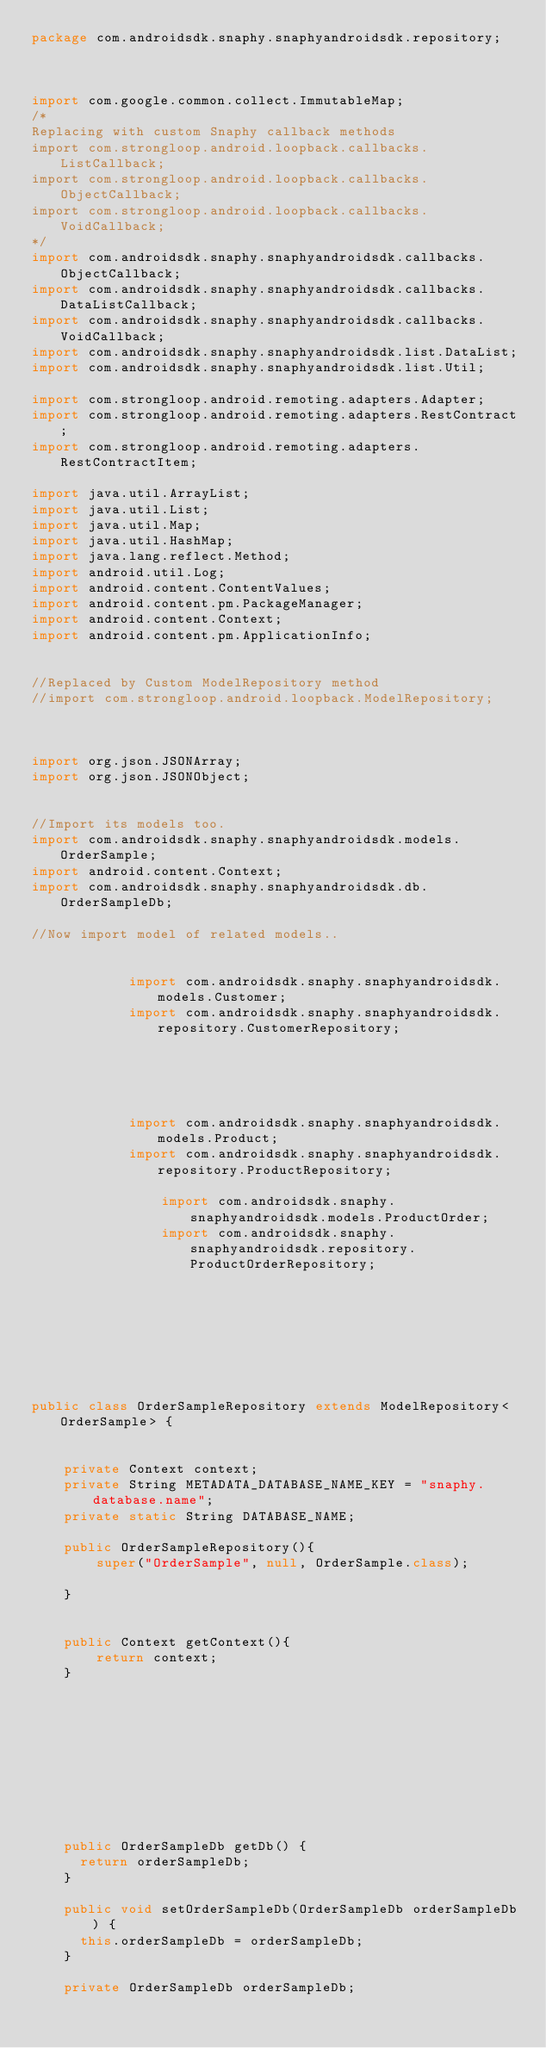Convert code to text. <code><loc_0><loc_0><loc_500><loc_500><_Java_>package com.androidsdk.snaphy.snaphyandroidsdk.repository;



import com.google.common.collect.ImmutableMap;
/*
Replacing with custom Snaphy callback methods
import com.strongloop.android.loopback.callbacks.ListCallback;
import com.strongloop.android.loopback.callbacks.ObjectCallback;
import com.strongloop.android.loopback.callbacks.VoidCallback;
*/
import com.androidsdk.snaphy.snaphyandroidsdk.callbacks.ObjectCallback;
import com.androidsdk.snaphy.snaphyandroidsdk.callbacks.DataListCallback;
import com.androidsdk.snaphy.snaphyandroidsdk.callbacks.VoidCallback;
import com.androidsdk.snaphy.snaphyandroidsdk.list.DataList;
import com.androidsdk.snaphy.snaphyandroidsdk.list.Util;

import com.strongloop.android.remoting.adapters.Adapter;
import com.strongloop.android.remoting.adapters.RestContract;
import com.strongloop.android.remoting.adapters.RestContractItem;

import java.util.ArrayList;
import java.util.List;
import java.util.Map;
import java.util.HashMap;
import java.lang.reflect.Method;
import android.util.Log;
import android.content.ContentValues;
import android.content.pm.PackageManager;
import android.content.Context;
import android.content.pm.ApplicationInfo;


//Replaced by Custom ModelRepository method
//import com.strongloop.android.loopback.ModelRepository;



import org.json.JSONArray;
import org.json.JSONObject;


//Import its models too.
import com.androidsdk.snaphy.snaphyandroidsdk.models.OrderSample;
import android.content.Context;
import com.androidsdk.snaphy.snaphyandroidsdk.db.OrderSampleDb;

//Now import model of related models..

    
            import com.androidsdk.snaphy.snaphyandroidsdk.models.Customer;
            import com.androidsdk.snaphy.snaphyandroidsdk.repository.CustomerRepository;
            
        
    

    
            import com.androidsdk.snaphy.snaphyandroidsdk.models.Product;
            import com.androidsdk.snaphy.snaphyandroidsdk.repository.ProductRepository;
            
                import com.androidsdk.snaphy.snaphyandroidsdk.models.ProductOrder;
                import com.androidsdk.snaphy.snaphyandroidsdk.repository.ProductOrderRepository;
            
        
    





public class OrderSampleRepository extends ModelRepository<OrderSample> {


    private Context context;
    private String METADATA_DATABASE_NAME_KEY = "snaphy.database.name";
    private static String DATABASE_NAME;

    public OrderSampleRepository(){
        super("OrderSample", null, OrderSample.class);

    }


    public Context getContext(){
        return context;
    }


    







    public OrderSampleDb getDb() {
      return orderSampleDb;
    }

    public void setOrderSampleDb(OrderSampleDb orderSampleDb) {
      this.orderSampleDb = orderSampleDb;
    }

    private OrderSampleDb orderSampleDb;


</code> 